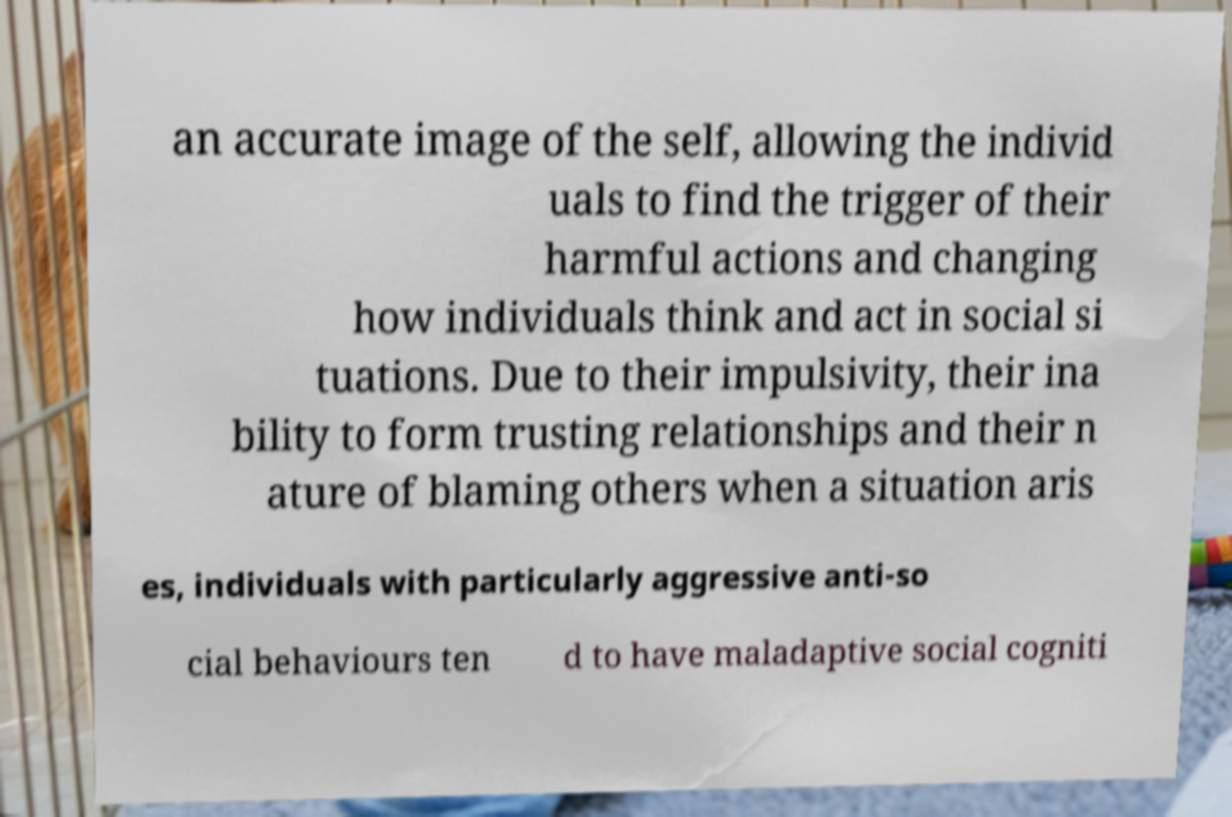There's text embedded in this image that I need extracted. Can you transcribe it verbatim? an accurate image of the self, allowing the individ uals to find the trigger of their harmful actions and changing how individuals think and act in social si tuations. Due to their impulsivity, their ina bility to form trusting relationships and their n ature of blaming others when a situation aris es, individuals with particularly aggressive anti-so cial behaviours ten d to have maladaptive social cogniti 